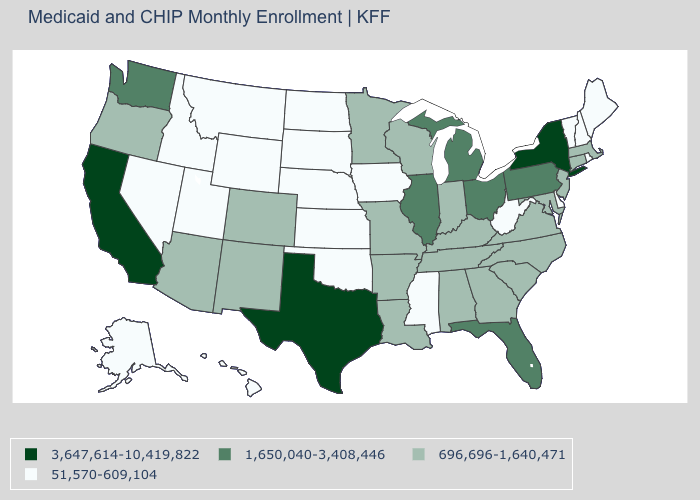Which states have the lowest value in the USA?
Short answer required. Alaska, Delaware, Hawaii, Idaho, Iowa, Kansas, Maine, Mississippi, Montana, Nebraska, Nevada, New Hampshire, North Dakota, Oklahoma, Rhode Island, South Dakota, Utah, Vermont, West Virginia, Wyoming. Does the first symbol in the legend represent the smallest category?
Quick response, please. No. What is the value of Arizona?
Short answer required. 696,696-1,640,471. What is the value of West Virginia?
Be succinct. 51,570-609,104. What is the value of Tennessee?
Concise answer only. 696,696-1,640,471. Does the map have missing data?
Quick response, please. No. Does California have a lower value than South Dakota?
Give a very brief answer. No. Among the states that border Florida , which have the lowest value?
Write a very short answer. Alabama, Georgia. What is the value of Maine?
Give a very brief answer. 51,570-609,104. What is the value of Maine?
Give a very brief answer. 51,570-609,104. What is the value of Alaska?
Write a very short answer. 51,570-609,104. Name the states that have a value in the range 51,570-609,104?
Give a very brief answer. Alaska, Delaware, Hawaii, Idaho, Iowa, Kansas, Maine, Mississippi, Montana, Nebraska, Nevada, New Hampshire, North Dakota, Oklahoma, Rhode Island, South Dakota, Utah, Vermont, West Virginia, Wyoming. Which states have the lowest value in the West?
Give a very brief answer. Alaska, Hawaii, Idaho, Montana, Nevada, Utah, Wyoming. Among the states that border Louisiana , which have the lowest value?
Keep it brief. Mississippi. 